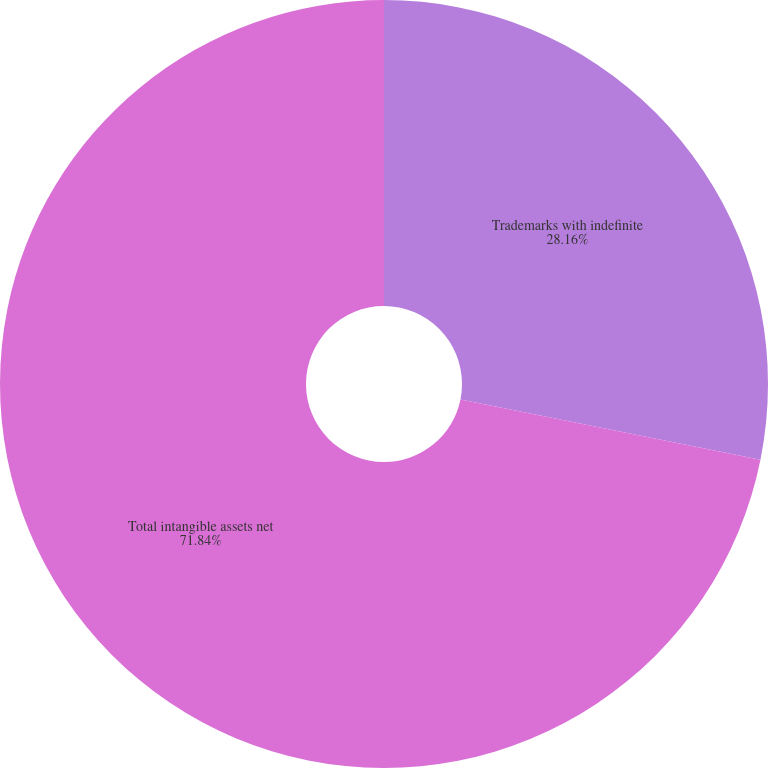Convert chart. <chart><loc_0><loc_0><loc_500><loc_500><pie_chart><fcel>Trademarks with indefinite<fcel>Total intangible assets net<nl><fcel>28.16%<fcel>71.84%<nl></chart> 